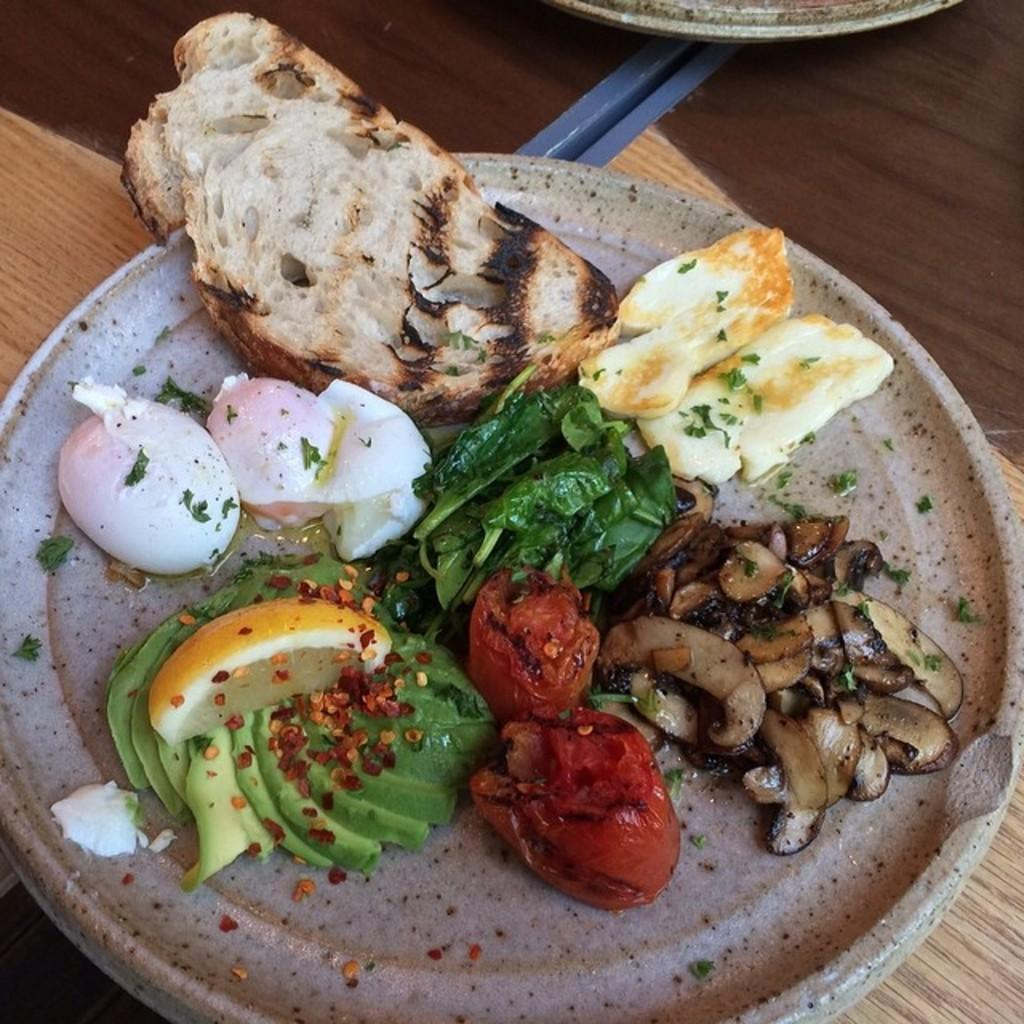What is present in the image related to food? There are food items in the image. How are the food items arranged or contained? The food items are in a plate. Where is the plate with food items located? The plate is placed on a platform. What holiday is being celebrated in the image? There is no indication of a holiday being celebrated in the image. 